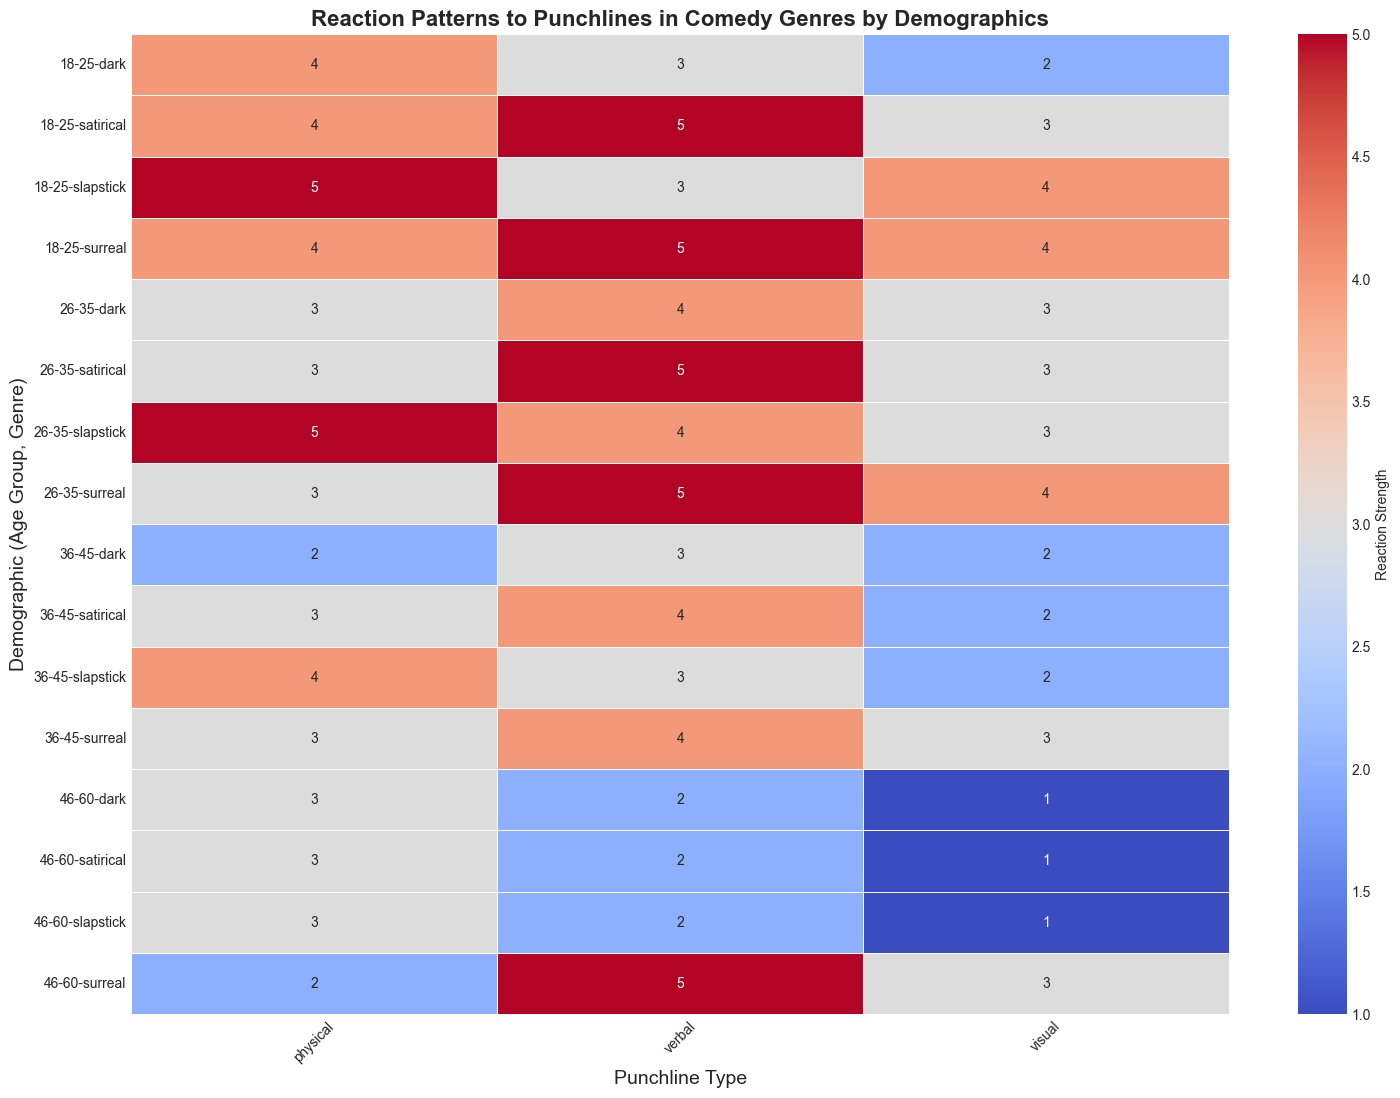What's the highest reaction strength for slapstick comedy in the age group 36-45? To find this, locate the row for slapstick and age 36-45 in the heatmap. Identify the highest value among visual, verbal, and physical punchlines.
Answer: great Which punchline type received the weakest reaction for surreal comedy in the age group 46-60? Find the row for surreal comedy and age group 46-60 in the heatmap. Look at the values for visual, verbal, and physical punchlines and identify the lowest value.
Answer: physical In satirical comedy, which age group shows the highest reaction strength to verbal punchlines? Locate satirical comedy rows and compare the columns under verbal punchlines for all age groups. Identify the row with the highest reaction strength.
Answer: 18-25 and 26-35 (tie) Compare reaction strengths for physical punchlines in slapstick comedy between the age groups 18-25 and 46-60. Which group has a higher reaction? Look at the values for physical punchlines in slapstick comedy, specifically for age groups 18-25 and 46-60. Compare these values.
Answer: 18-25 Which age group and genre combination shows the poorest reaction to visual punchlines? Scan the visual punchline column for the lowest values across all age and genre combinations.
Answer: slapstick, 46-60 and satirical, 46-60 (tie) What is the average reaction strength for physical punchlines in dark comedy across all age groups? Note the values of physical punchlines for dark comedy across all four age groups: 18-25 (3), 26-35 (3), 36-45 (2), and 46-60 (3). Sum them up and divide by the number of age groups. (2 + 3 + 3 + 2) / 4 = 2.5
Answer: 2.75 For which genre does the 26-35 age group show equal reaction strength to both verbal and physical punchlines? Identify reaction strengths for verbal and physical punchlines in the 26-35 age group across all genres. Find where they are equal.
Answer: dark What is the difference in reaction strength between slapstick's verbal and physical punchlines in the age group 36-45? Identify values for verbal (3) and physical (4) punchlines in slapstick comedy, age group 36-45. Subtract verbal from physical: 4 - 3 = 1.
Answer: 1 Which genre has the least variation in reaction strengths across punchline types for the 18-25 age group? Compare reaction strengths across punchline types (visual, verbal, physical) within each genre for the 18-25 age group. Identify the genre with the smallest range of values.
Answer: surreal (values are all 4 or 5) 